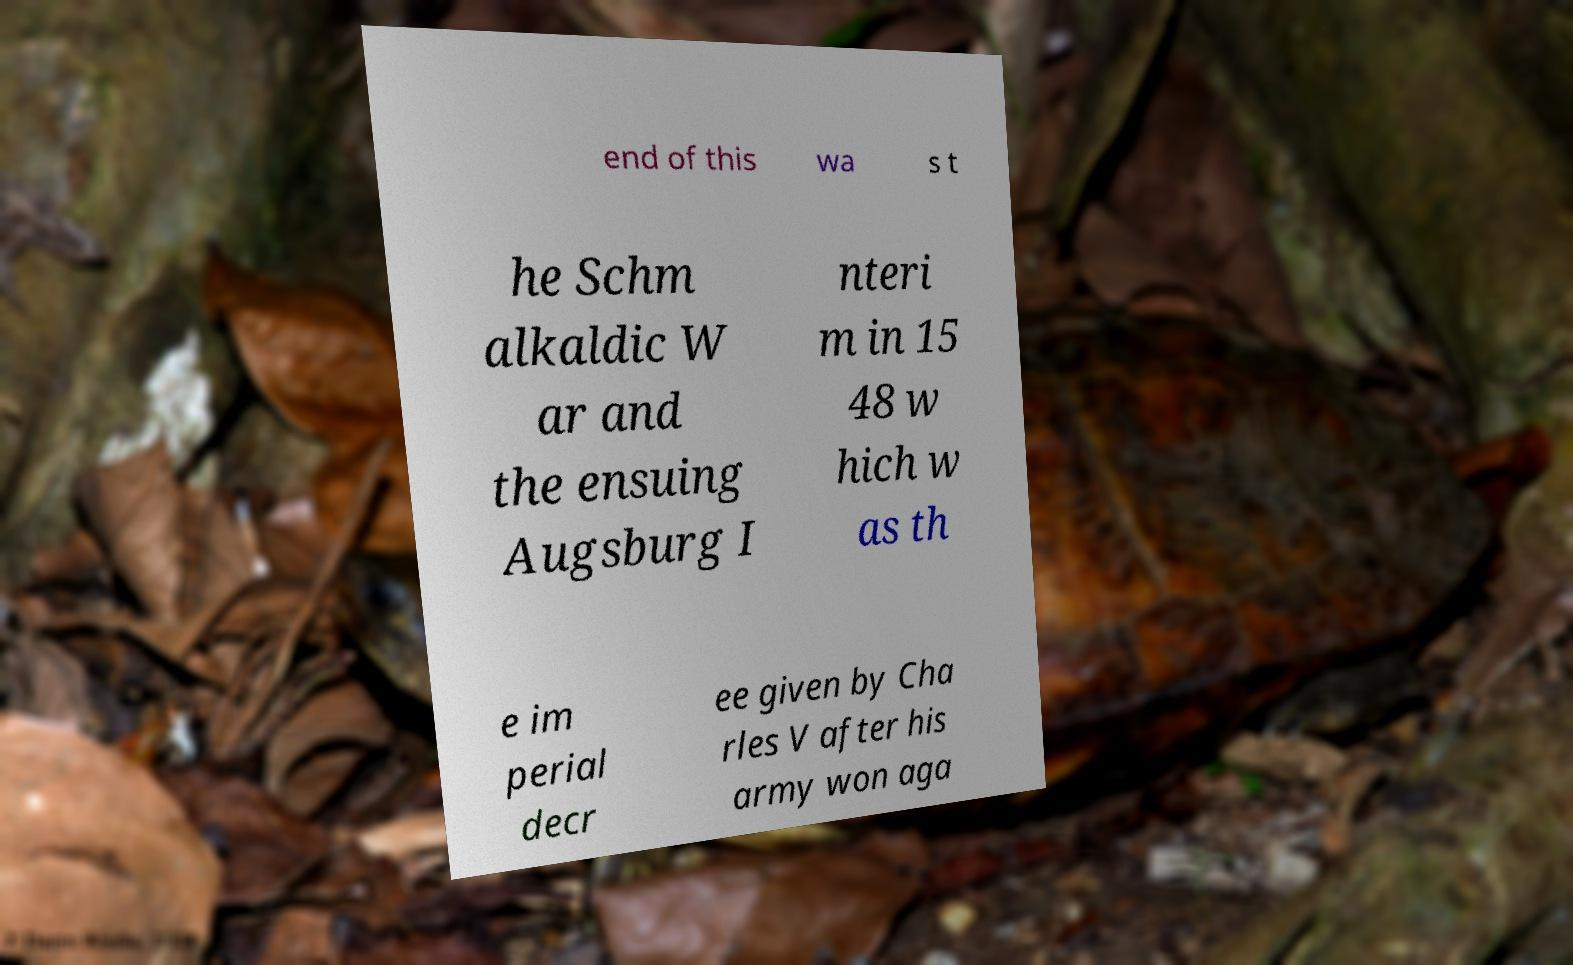Can you read and provide the text displayed in the image?This photo seems to have some interesting text. Can you extract and type it out for me? end of this wa s t he Schm alkaldic W ar and the ensuing Augsburg I nteri m in 15 48 w hich w as th e im perial decr ee given by Cha rles V after his army won aga 